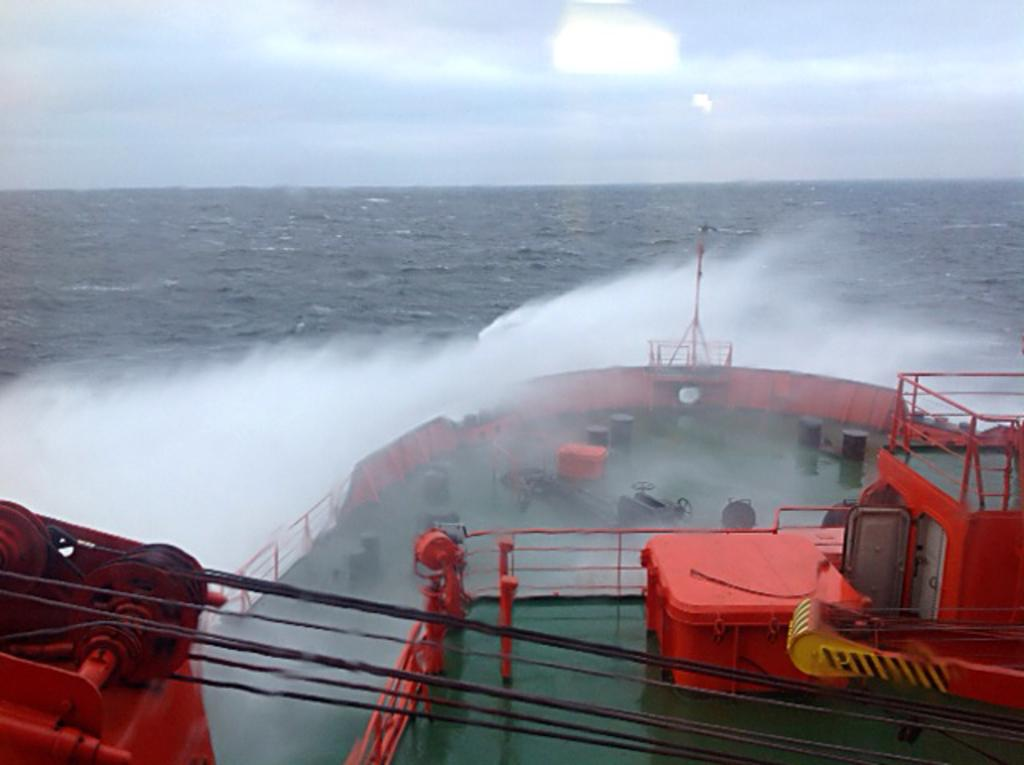What is the main subject of the image? There is a ship in the image. Where is the ship located? The ship is in the water. What can be seen in the sky in the image? There are clouds visible in the sky. What type of orange can be seen hanging from the ship's mast in the image? There is no orange present in the image, and therefore no such object can be observed hanging from the ship's mast. 